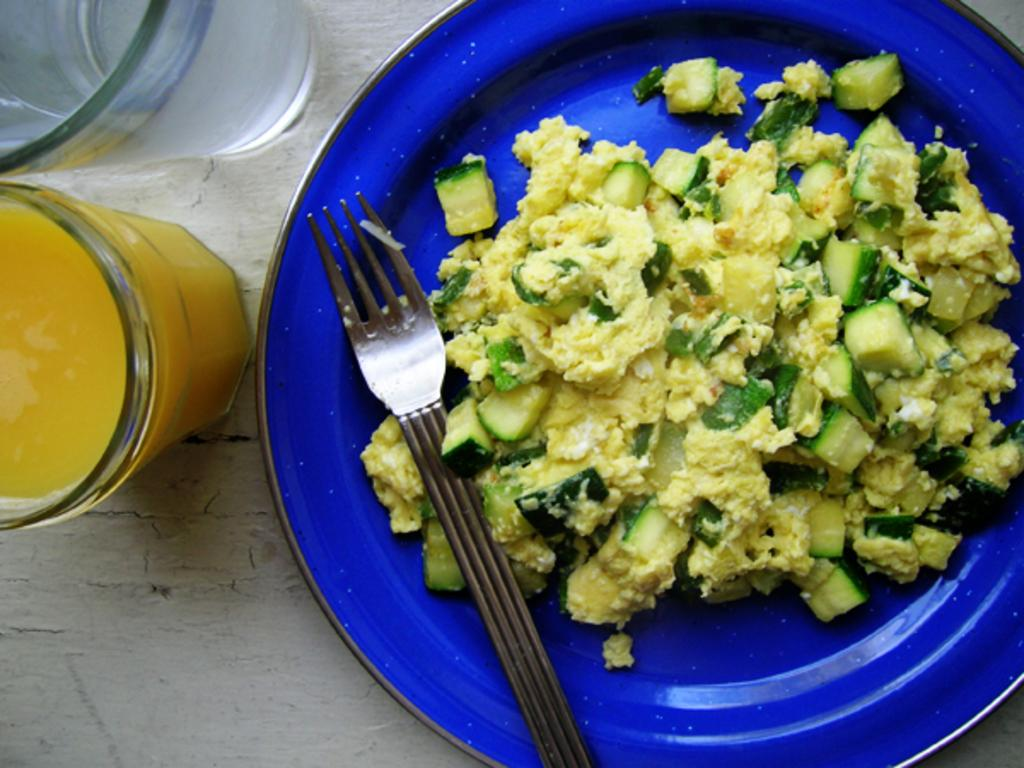What objects are present in the image that are typically used for eating or drinking? There are glasses, a fork, and food on a plate in the image. What type of surface can be seen in the background of the image? There is a table in the background of the image. What month is depicted in the image? There is no indication of a specific month in the image. What type of operation is being performed in the image? There is no operation or medical procedure depicted in the image. 